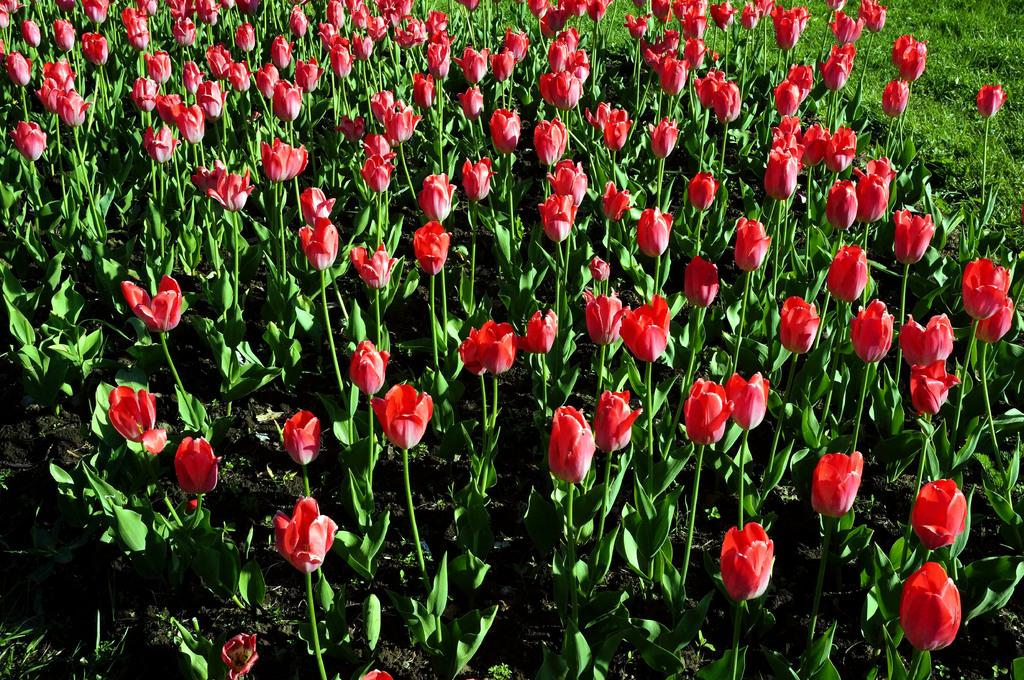What type of living organisms are in the image? There is a group of plants in the image. What specific feature can be observed on the plants? The plants have flowers. What type of vegetation is also present in the image? There is grass in the image. How many cherries can be seen on the plants in the image? There are no cherries present in the image; it features a group of plants with flowers. What type of weather condition is suggested by the presence of snow in the image? There is no snow present in the image, so it cannot be used to suggest any weather conditions. 